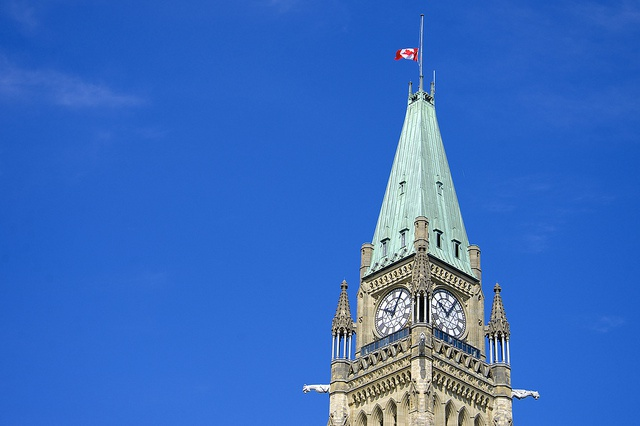Describe the objects in this image and their specific colors. I can see clock in blue, white, darkgray, and gray tones and clock in blue, white, darkgray, and gray tones in this image. 